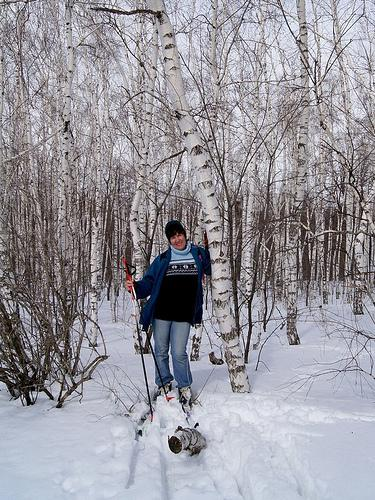Question: what type of pants is the woman wearing?
Choices:
A. Slacks.
B. Blue jeans.
C. Khakis.
D. Bell bottoms.
Answer with the letter. Answer: B Question: who is wearing a blue jacket?
Choices:
A. The woman.
B. The girl.
C. The man.
D. The boy.
Answer with the letter. Answer: A 